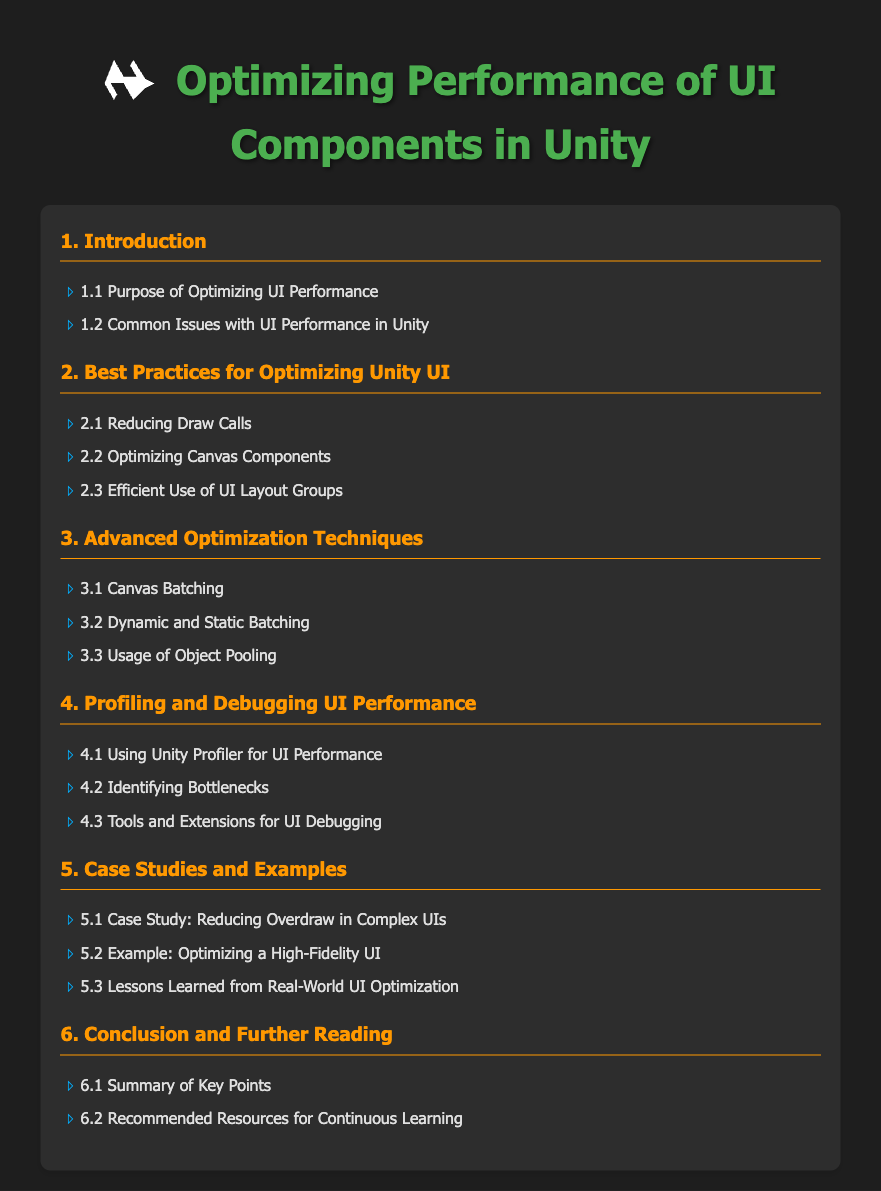What is the first section of the table of contents? The first section listed under the table of contents is "1. Introduction".
Answer: 1. Introduction What is the purpose of optimizing UI performance mentioned in the document? This topic is discussed in subsection 1.1 of the first section.
Answer: Purpose of Optimizing UI Performance Which optimization technique focuses on managing memory usage effectively? This technique is discussed in subsection 3.3 regarding object management.
Answer: Usage of Object Pooling How many subsections are listed under the "Best Practices for Optimizing Unity UI" section? There are three subsections listed under this section in the table of contents.
Answer: 3 What tool is mentioned for profiling UI performance? This tool is covered in subsection 4.1 of the fourth section.
Answer: Unity Profiler Which case study focuses on reducing overdraw in complex UIs? This case study is listed as subsection 5.1 in the fifth section.
Answer: Case Study: Reducing Overdraw in Complex UIs What is the last section in the table of contents? The last section focuses on summarizing key points and further reading resources.
Answer: 6. Conclusion and Further Reading What color is used for the section titles in the table of contents? The section titles are emphasized with a specific color detailing the formatting.
Answer: Orange 